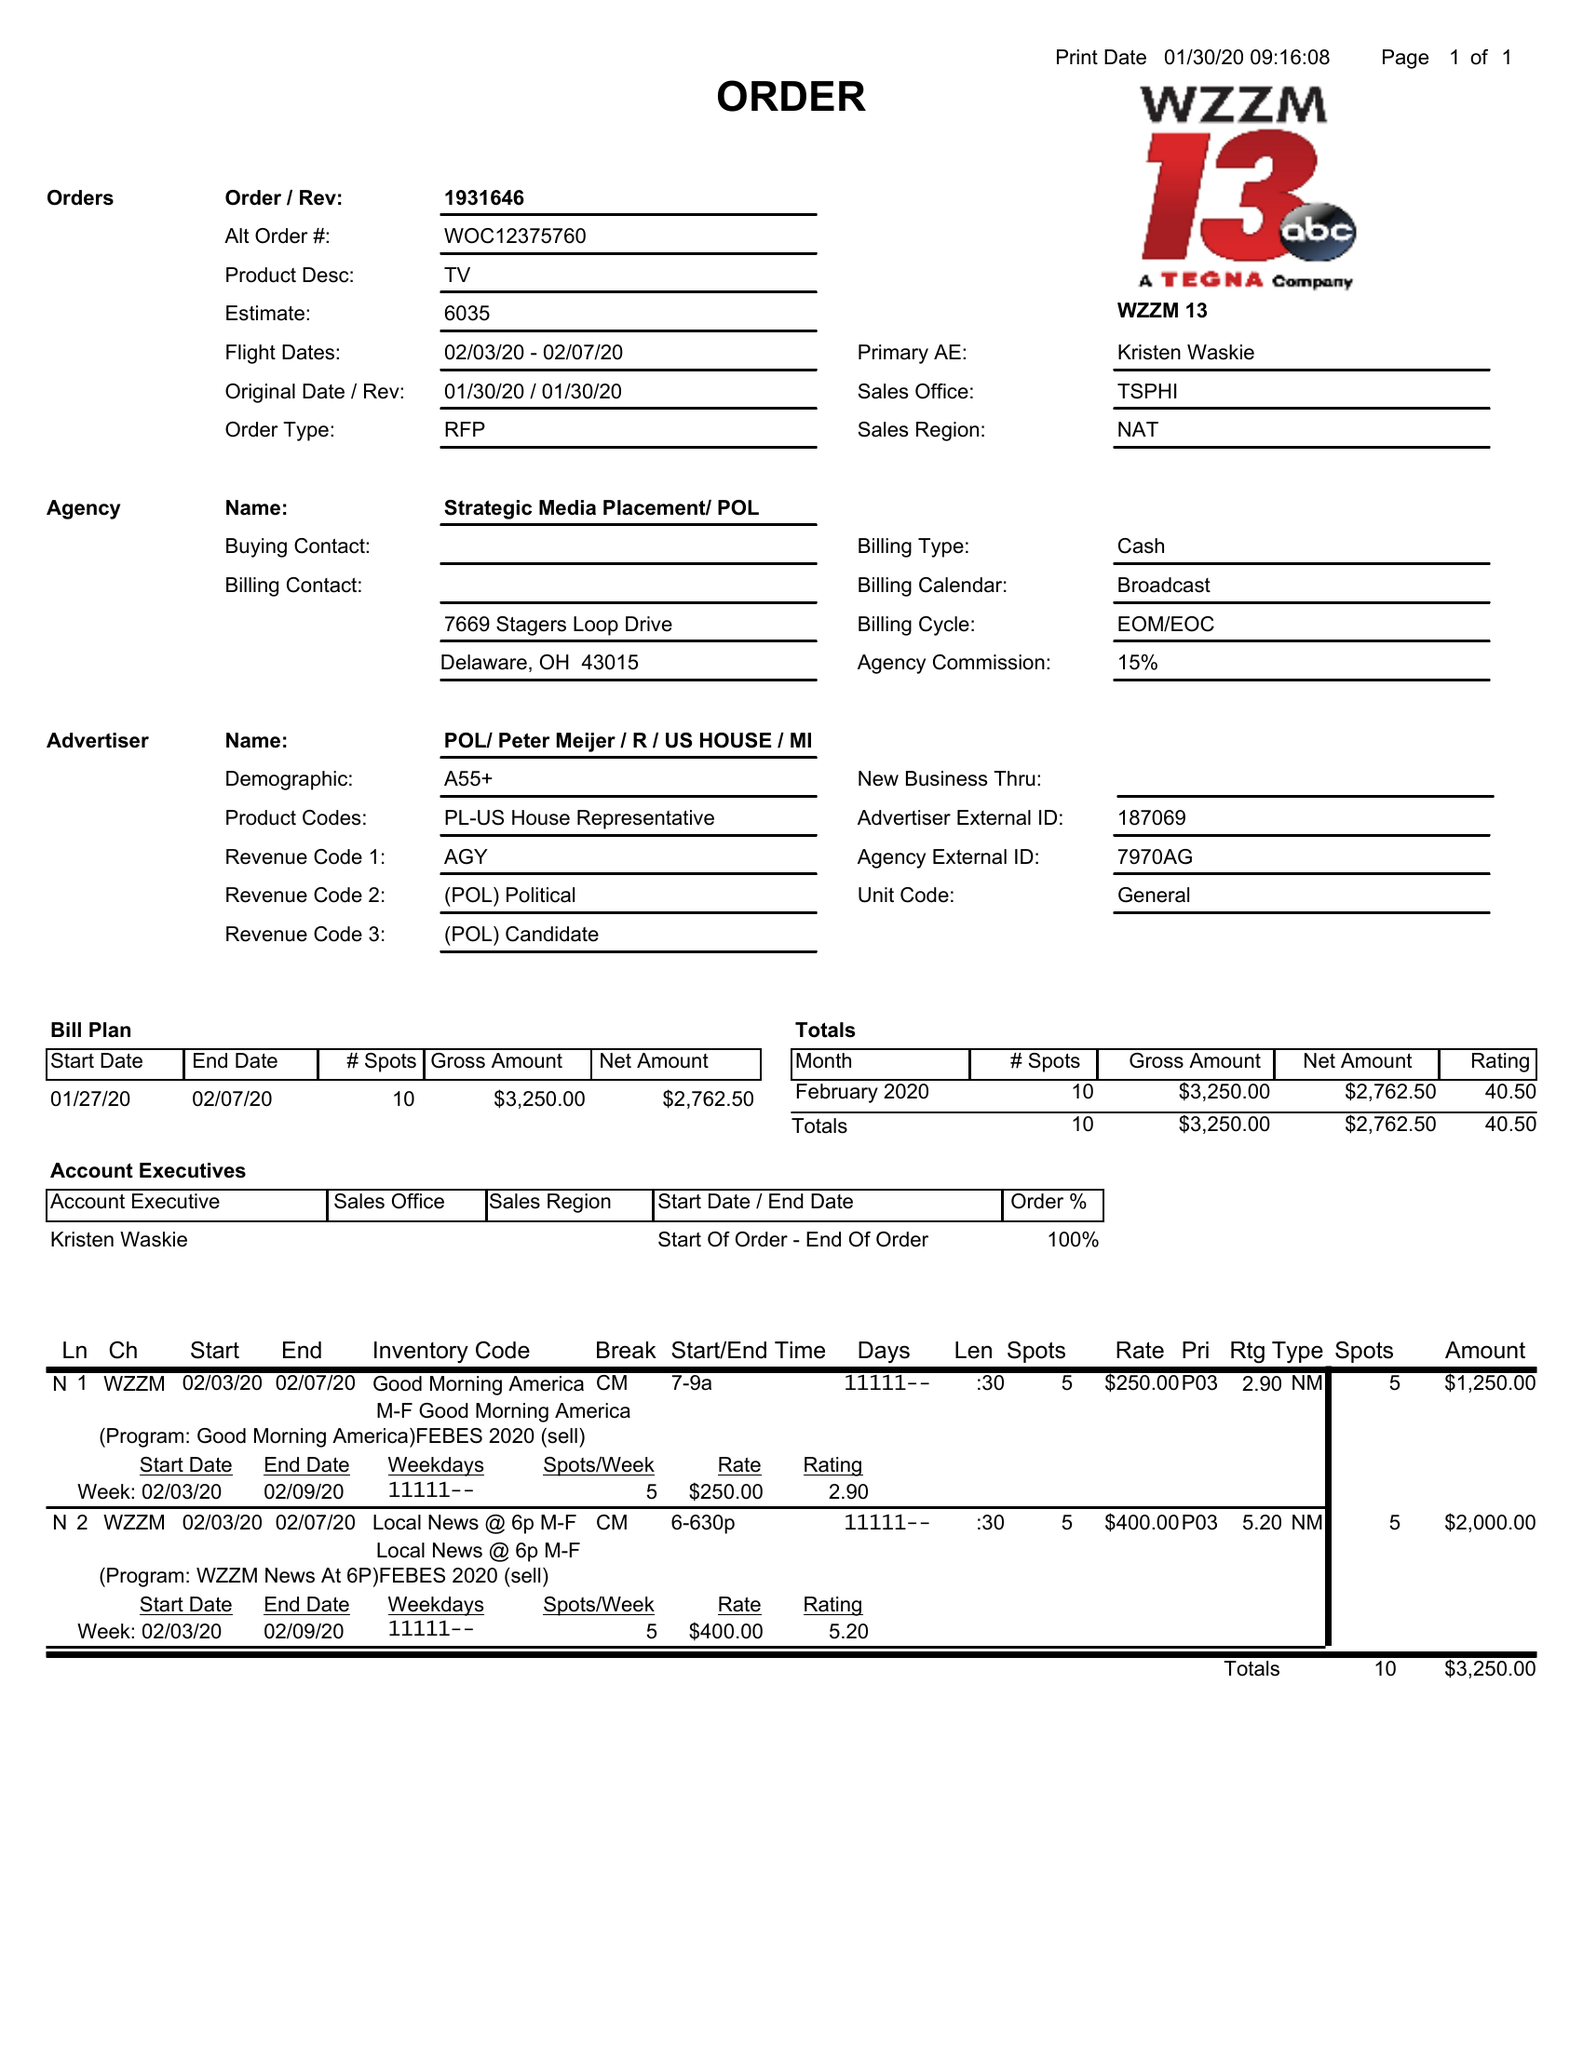What is the value for the flight_from?
Answer the question using a single word or phrase. 02/03/20 